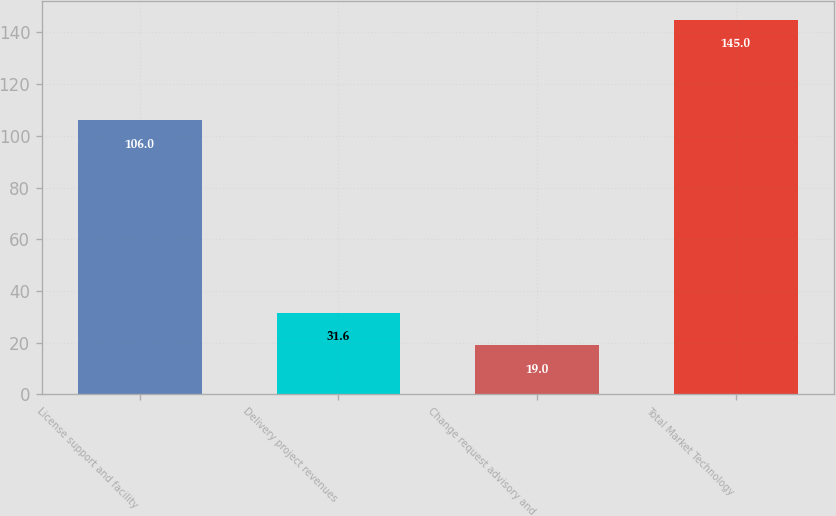<chart> <loc_0><loc_0><loc_500><loc_500><bar_chart><fcel>License support and facility<fcel>Delivery project revenues<fcel>Change request advisory and<fcel>Total Market Technology<nl><fcel>106<fcel>31.6<fcel>19<fcel>145<nl></chart> 